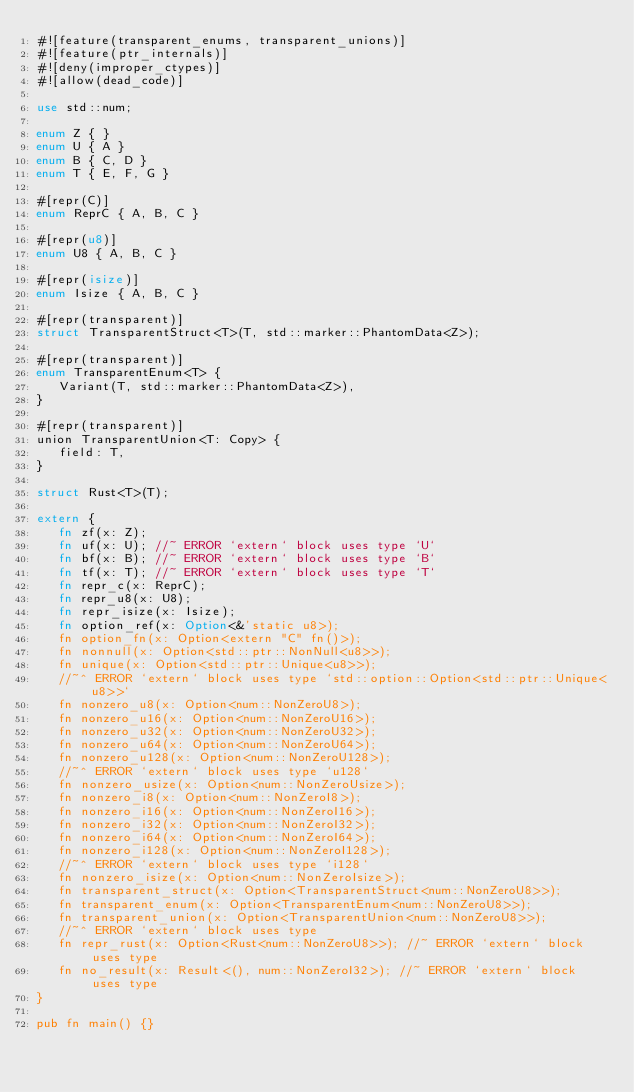<code> <loc_0><loc_0><loc_500><loc_500><_Rust_>#![feature(transparent_enums, transparent_unions)]
#![feature(ptr_internals)]
#![deny(improper_ctypes)]
#![allow(dead_code)]

use std::num;

enum Z { }
enum U { A }
enum B { C, D }
enum T { E, F, G }

#[repr(C)]
enum ReprC { A, B, C }

#[repr(u8)]
enum U8 { A, B, C }

#[repr(isize)]
enum Isize { A, B, C }

#[repr(transparent)]
struct TransparentStruct<T>(T, std::marker::PhantomData<Z>);

#[repr(transparent)]
enum TransparentEnum<T> {
   Variant(T, std::marker::PhantomData<Z>),
}

#[repr(transparent)]
union TransparentUnion<T: Copy> {
   field: T,
}

struct Rust<T>(T);

extern {
   fn zf(x: Z);
   fn uf(x: U); //~ ERROR `extern` block uses type `U`
   fn bf(x: B); //~ ERROR `extern` block uses type `B`
   fn tf(x: T); //~ ERROR `extern` block uses type `T`
   fn repr_c(x: ReprC);
   fn repr_u8(x: U8);
   fn repr_isize(x: Isize);
   fn option_ref(x: Option<&'static u8>);
   fn option_fn(x: Option<extern "C" fn()>);
   fn nonnull(x: Option<std::ptr::NonNull<u8>>);
   fn unique(x: Option<std::ptr::Unique<u8>>);
   //~^ ERROR `extern` block uses type `std::option::Option<std::ptr::Unique<u8>>`
   fn nonzero_u8(x: Option<num::NonZeroU8>);
   fn nonzero_u16(x: Option<num::NonZeroU16>);
   fn nonzero_u32(x: Option<num::NonZeroU32>);
   fn nonzero_u64(x: Option<num::NonZeroU64>);
   fn nonzero_u128(x: Option<num::NonZeroU128>);
   //~^ ERROR `extern` block uses type `u128`
   fn nonzero_usize(x: Option<num::NonZeroUsize>);
   fn nonzero_i8(x: Option<num::NonZeroI8>);
   fn nonzero_i16(x: Option<num::NonZeroI16>);
   fn nonzero_i32(x: Option<num::NonZeroI32>);
   fn nonzero_i64(x: Option<num::NonZeroI64>);
   fn nonzero_i128(x: Option<num::NonZeroI128>);
   //~^ ERROR `extern` block uses type `i128`
   fn nonzero_isize(x: Option<num::NonZeroIsize>);
   fn transparent_struct(x: Option<TransparentStruct<num::NonZeroU8>>);
   fn transparent_enum(x: Option<TransparentEnum<num::NonZeroU8>>);
   fn transparent_union(x: Option<TransparentUnion<num::NonZeroU8>>);
   //~^ ERROR `extern` block uses type
   fn repr_rust(x: Option<Rust<num::NonZeroU8>>); //~ ERROR `extern` block uses type
   fn no_result(x: Result<(), num::NonZeroI32>); //~ ERROR `extern` block uses type
}

pub fn main() {}
</code> 